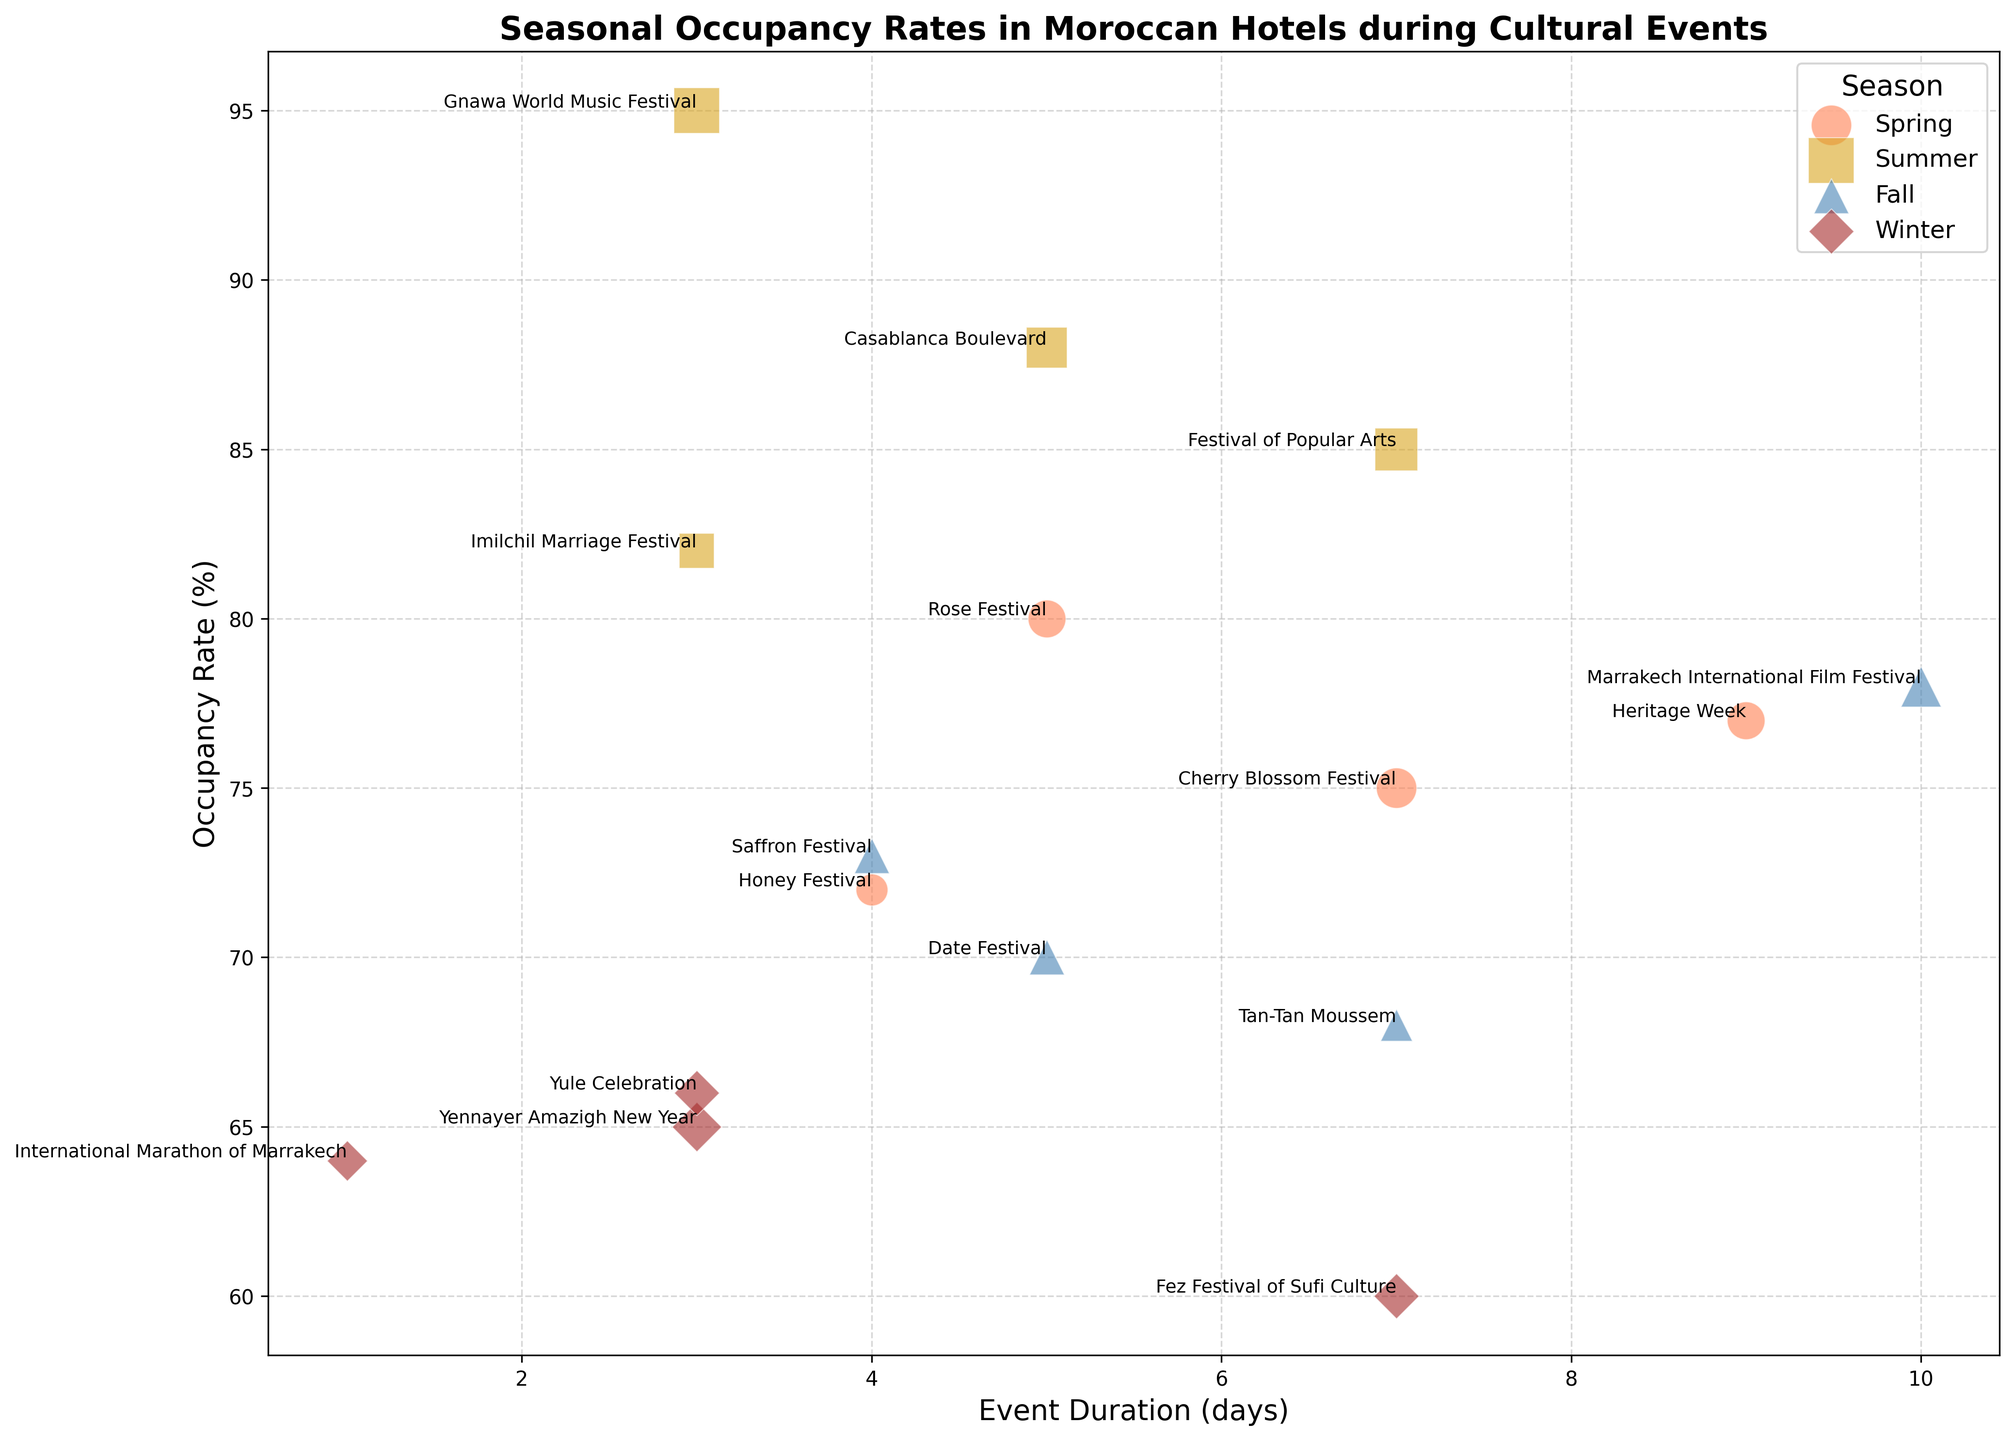Which season has the highest occupancy rate during cultural events? The plot shows bubbles representing events in different seasons. By comparing the vertical positions related to occupancy rates, we observe that summer events have the highest occupancy rates.
Answer: Summer What is the relationship between event duration and occupancy rate for the Rose Festival and Heritage Week? The Rose Festival in Spring has a duration of 5 days and an occupancy rate of 80%. The Heritage Week, also in Spring, has a duration of 9 days and an occupancy rate of 77%. Heritage Week has a longer duration but a slightly lower occupancy rate than the Rose Festival.
Answer: Heritage Week has a longer duration but a slightly lower occupancy rate Which event has the largest bubble size in summer, and what does it represent? The Gnawa World Music Festival bubble is the largest in summer, indicated by its size. The larger size represents the event having the highest popularity rating among summer events.
Answer: Gnawa World Music Festival How does the occupancy rate of the Fez Festival of Sufi Culture compare with the Yennayer Amazigh New Year? The Fez Festival of Sufi Culture in winter has an occupancy rate of 60%, while the Yennayer Amazigh New Year has a 65% occupancy rate in the same season.
Answer: Yennayer Amazigh New Year's occupancy rate is higher Which event during fall has the lowest occupancy rate and how long does it last? By comparing the sizes and positions of bubbles in the fall, we can see that the Tan-Tan Moussem event has the lowest occupancy rate of 68% and lasts for 7 days.
Answer: Tan-Tan Moussem has the lowest occupancy rate and lasts for 7 days What is the average occupancy rate of the events in winter? The occupancy rates for winter events are 60% (Fez Festival), 65% (Yennayer Amazigh New Year), 64% (International Marathon of Marrakech), and 66% (Yule Celebration). Summing these up gives 60+65+64+66=255, and there are 4 events. So, the average is 255/4 = 63.75%
Answer: 63.75% Among the events in spring, which event has the shortest duration and what is its occupancy rate? Referring to the plot, the Honey Festival has the shortest duration of 4 days among spring events, and its occupancy rate is 72%.
Answer: Honey Festival with 72% occupancy rate Is there any event in the fall season which lasts for exactly 5 days? If so, what is its occupancy rate? Looking at the fall events, the Date Festival has an event duration of 5 days and an occupancy rate of 70%.
Answer: Date Festival with 70% Which season generally has the highest durations for cultural events, based on the plotted data? By comparing the position of events along the horizontal axis (Event Duration), fall events generally show higher durations, with several events having durations of 7 days or more.
Answer: Fall What is the occupancy rate difference between the event with the highest popularity in spring and the event with the highest popularity in winter? The most popular spring event is the Cherry Blossom Festival (popularity 8) with an occupancy rate of 75%. The most popular winter event is the Fez Festival of Sufi Culture (popularity 5) with an occupancy rate of 60%. The difference is 75% - 60% = 15%.
Answer: 15% 